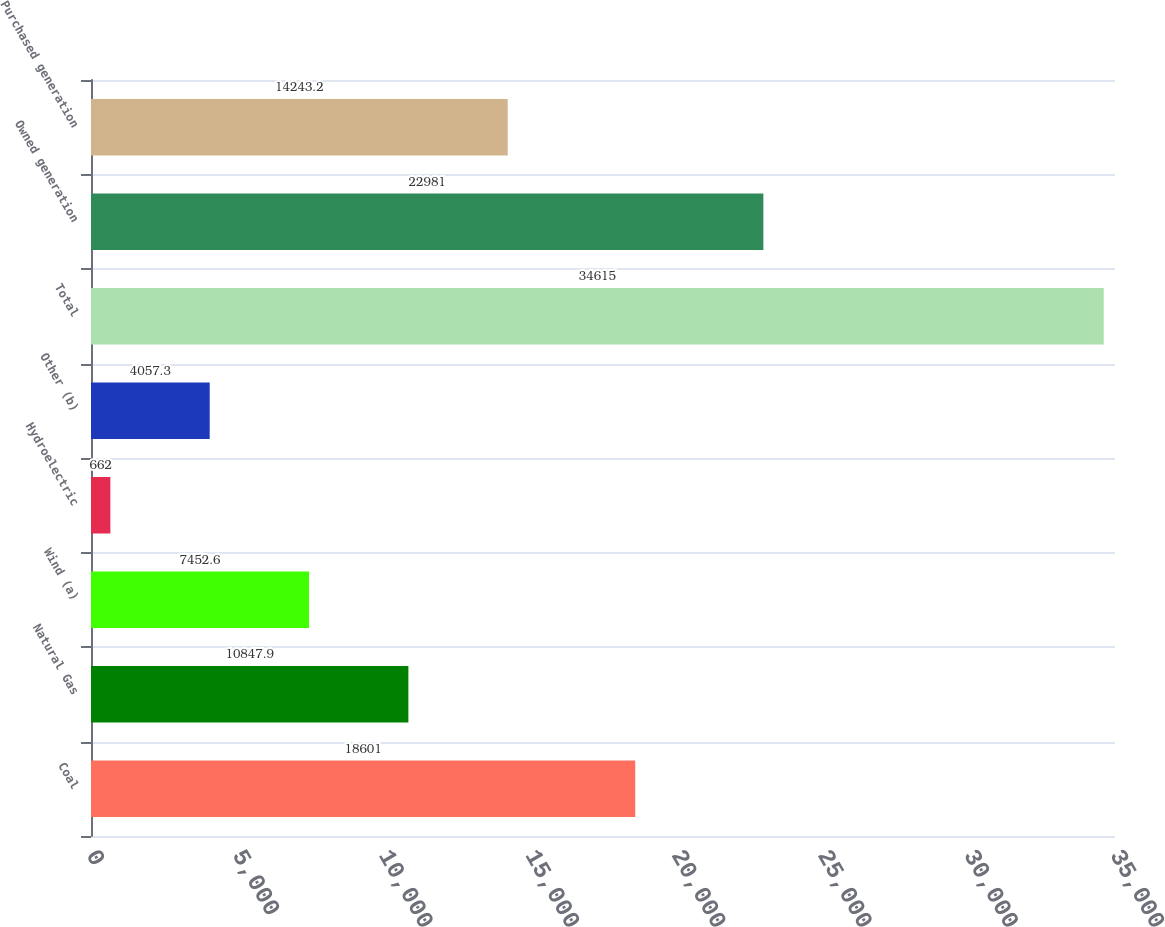<chart> <loc_0><loc_0><loc_500><loc_500><bar_chart><fcel>Coal<fcel>Natural Gas<fcel>Wind (a)<fcel>Hydroelectric<fcel>Other (b)<fcel>Total<fcel>Owned generation<fcel>Purchased generation<nl><fcel>18601<fcel>10847.9<fcel>7452.6<fcel>662<fcel>4057.3<fcel>34615<fcel>22981<fcel>14243.2<nl></chart> 